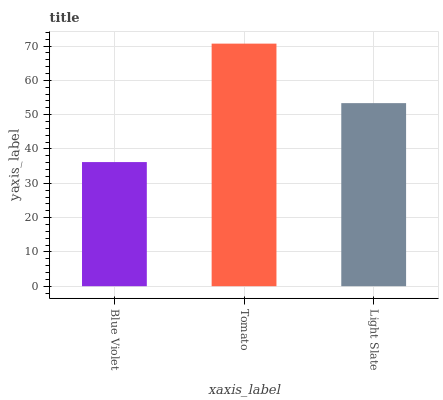Is Blue Violet the minimum?
Answer yes or no. Yes. Is Tomato the maximum?
Answer yes or no. Yes. Is Light Slate the minimum?
Answer yes or no. No. Is Light Slate the maximum?
Answer yes or no. No. Is Tomato greater than Light Slate?
Answer yes or no. Yes. Is Light Slate less than Tomato?
Answer yes or no. Yes. Is Light Slate greater than Tomato?
Answer yes or no. No. Is Tomato less than Light Slate?
Answer yes or no. No. Is Light Slate the high median?
Answer yes or no. Yes. Is Light Slate the low median?
Answer yes or no. Yes. Is Blue Violet the high median?
Answer yes or no. No. Is Blue Violet the low median?
Answer yes or no. No. 